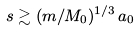<formula> <loc_0><loc_0><loc_500><loc_500>s \gtrsim ( m / M _ { 0 } ) ^ { 1 / 3 } \, a _ { 0 }</formula> 